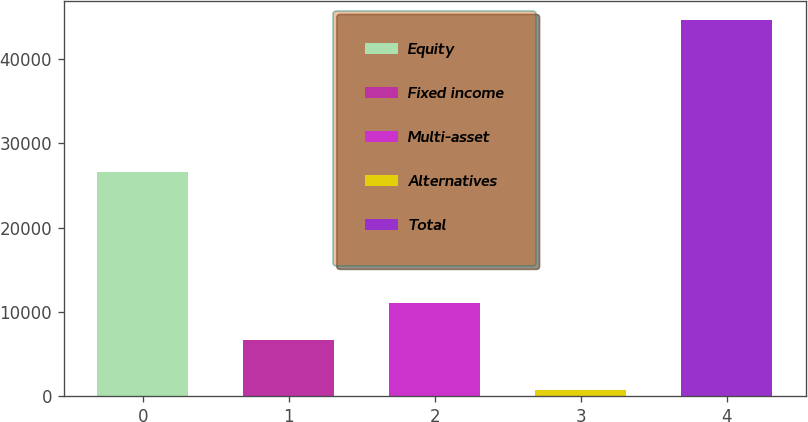Convert chart. <chart><loc_0><loc_0><loc_500><loc_500><bar_chart><fcel>Equity<fcel>Fixed income<fcel>Multi-asset<fcel>Alternatives<fcel>Total<nl><fcel>26598<fcel>6655<fcel>11049<fcel>708<fcel>44648<nl></chart> 